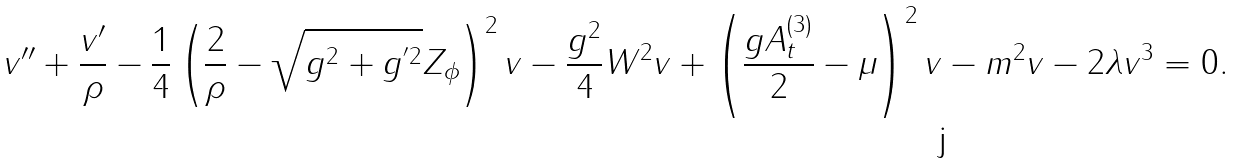Convert formula to latex. <formula><loc_0><loc_0><loc_500><loc_500>v ^ { \prime \prime } + \frac { v ^ { \prime } } { \rho } - \frac { 1 } { 4 } \left ( \frac { 2 } { \rho } - \sqrt { g ^ { 2 } + g ^ { ^ { \prime } 2 } } Z _ { \phi } \right ) ^ { 2 } v - \frac { g ^ { 2 } } { 4 } W ^ { 2 } v + \left ( \frac { g A _ { t } ^ { ( 3 ) } } { 2 } - \mu \right ) ^ { 2 } v - m ^ { 2 } v - 2 \lambda v ^ { 3 } = 0 .</formula> 